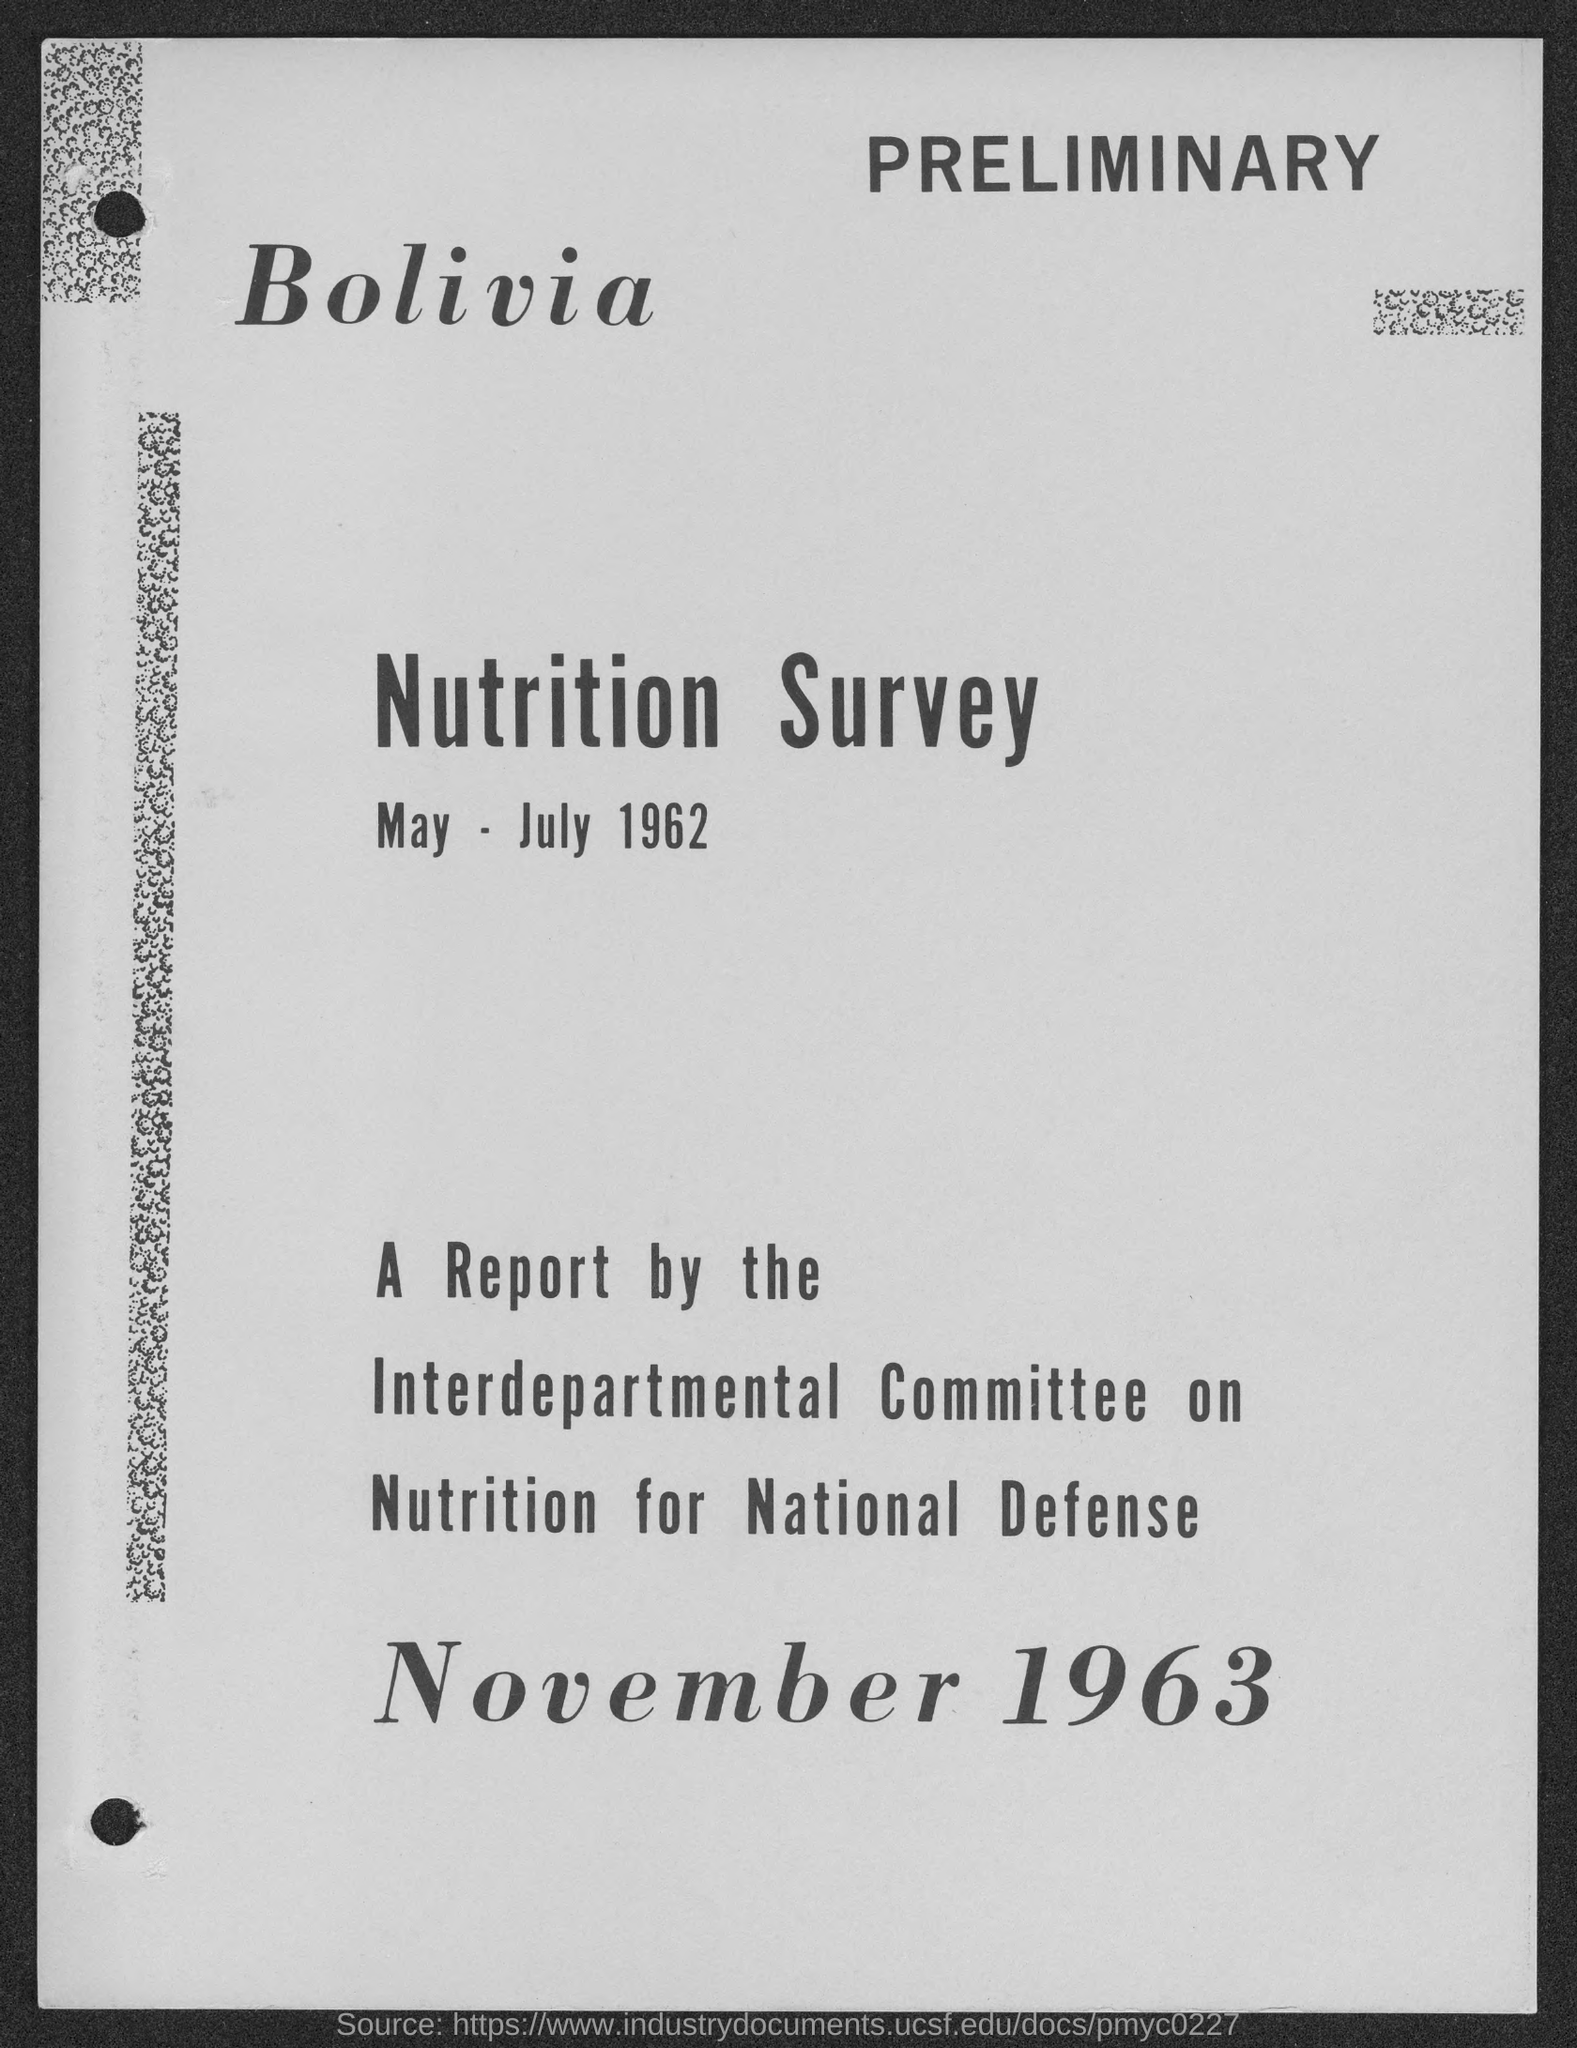Give some essential details in this illustration. The date mentioned at the bottom of the document is November 1963. The date specified in the top of the document is May-July 1962. 